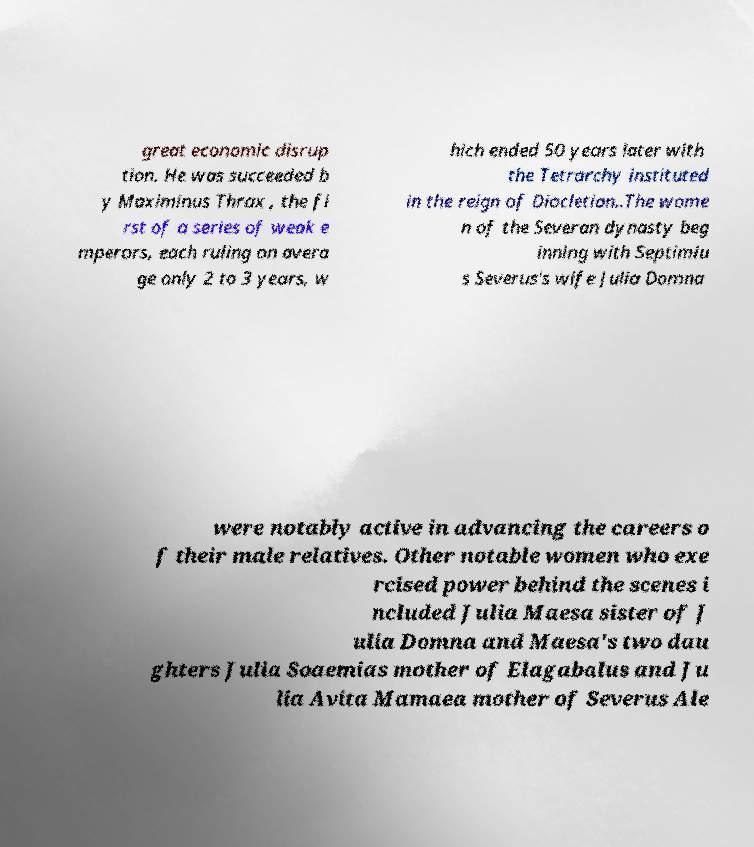Can you accurately transcribe the text from the provided image for me? great economic disrup tion. He was succeeded b y Maximinus Thrax , the fi rst of a series of weak e mperors, each ruling on avera ge only 2 to 3 years, w hich ended 50 years later with the Tetrarchy instituted in the reign of Diocletian..The wome n of the Severan dynasty beg inning with Septimiu s Severus's wife Julia Domna were notably active in advancing the careers o f their male relatives. Other notable women who exe rcised power behind the scenes i ncluded Julia Maesa sister of J ulia Domna and Maesa's two dau ghters Julia Soaemias mother of Elagabalus and Ju lia Avita Mamaea mother of Severus Ale 